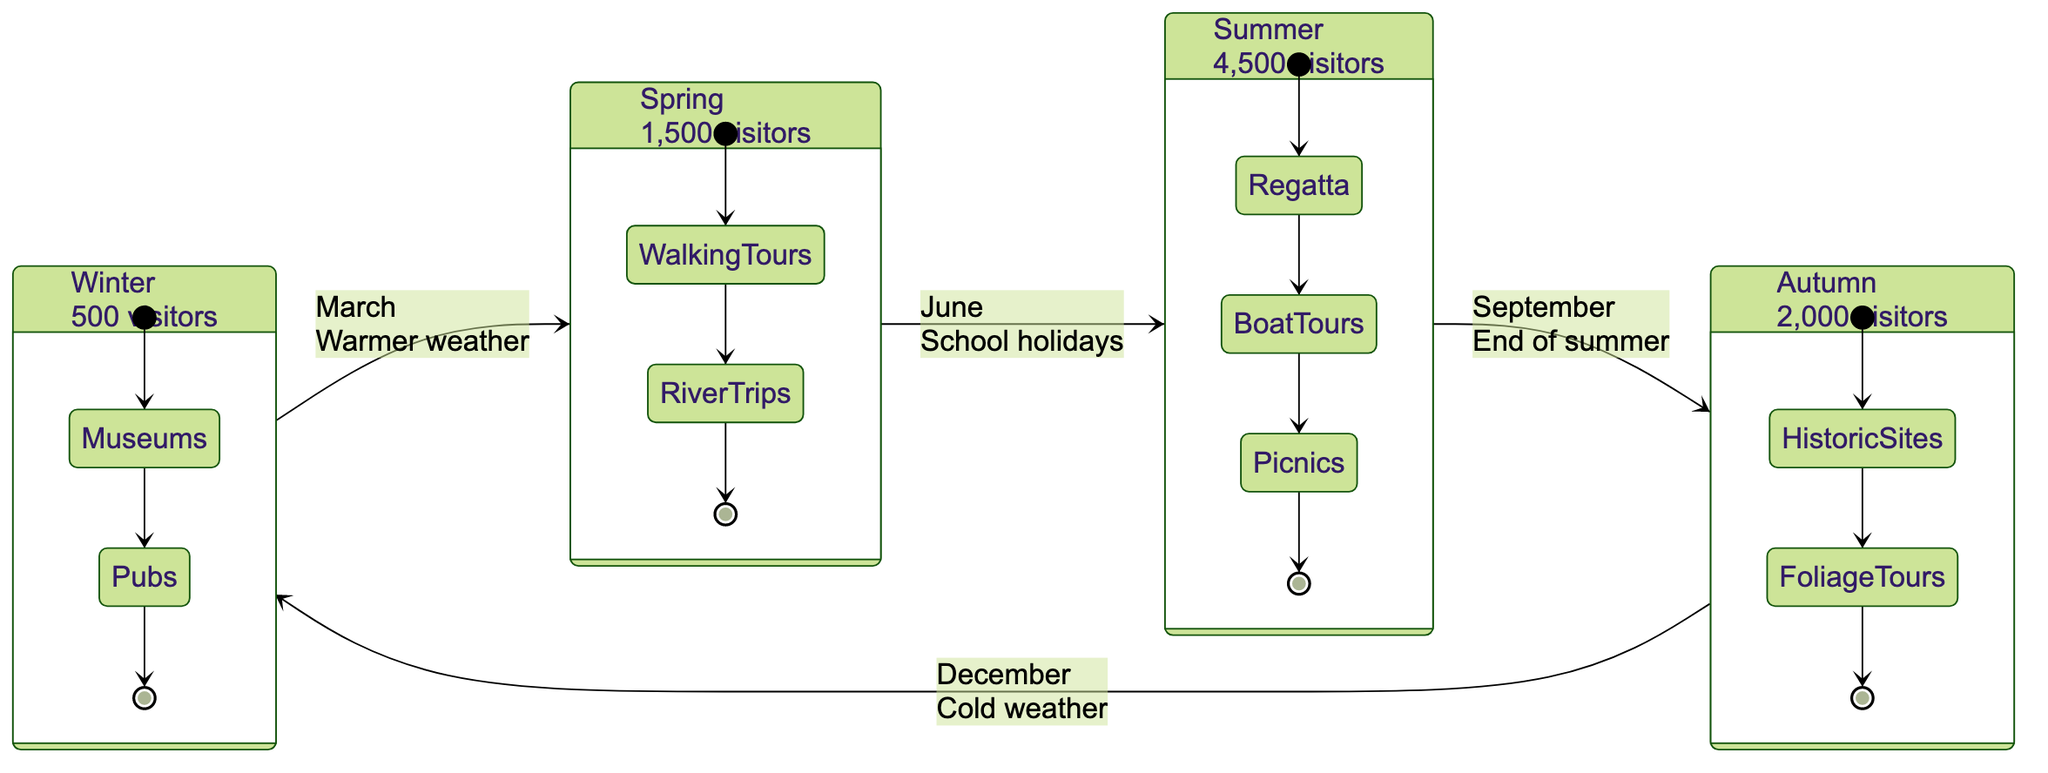What is the average number of visitors during Summer? The diagram indicates that during the Summer state, there are 4,500 average visitors listed.
Answer: 4,500 What are the popular activities in Winter? In the Winter state, the popular activities listed are "Visits to local museums" and "Fireplace dining in traditional pubs".
Answer: Visits to local museums, Fireplace dining in traditional pubs Which season shows a gradual increase in tourists? The Spring season is described as having a "Gradual increase in tourists", indicating an upward trend from Winter.
Answer: Spring What transition occurs from Summer to Autumn? The diagram states that the transition from Summer to Autumn happens in September, indicating the "End of summer holidays and cooler weather" as the condition for this transition.
Answer: September How many total states are shown in the diagram? The diagram contains four states: Winter, Spring, Summer, and Autumn, making it a total of four states present in the diagram.
Answer: 4 What condition leads to the transition from Winter to Spring? The transition from Winter to Spring occurs in March, triggered by the condition of "Warmer weather encourages more outdoor activities".
Answer: March What are the popular activities in Autumn? According to the diagram, the popular activities during Autumn are "Historic site visits" and "Autumn foliage tours at Sunbury Park".
Answer: Historic site visits, Autumn foliage tours at Sunbury Park Which season has the least average visitors? Winter has the least average visitors with a count of 500, making it the state with the lowest tourist activity.
Answer: Winter What describes the visitor trend in Summer? The Summer state is defined as "Peak tourist season", reflecting the highest tourist activity compared to other seasons.
Answer: Peak tourist season 